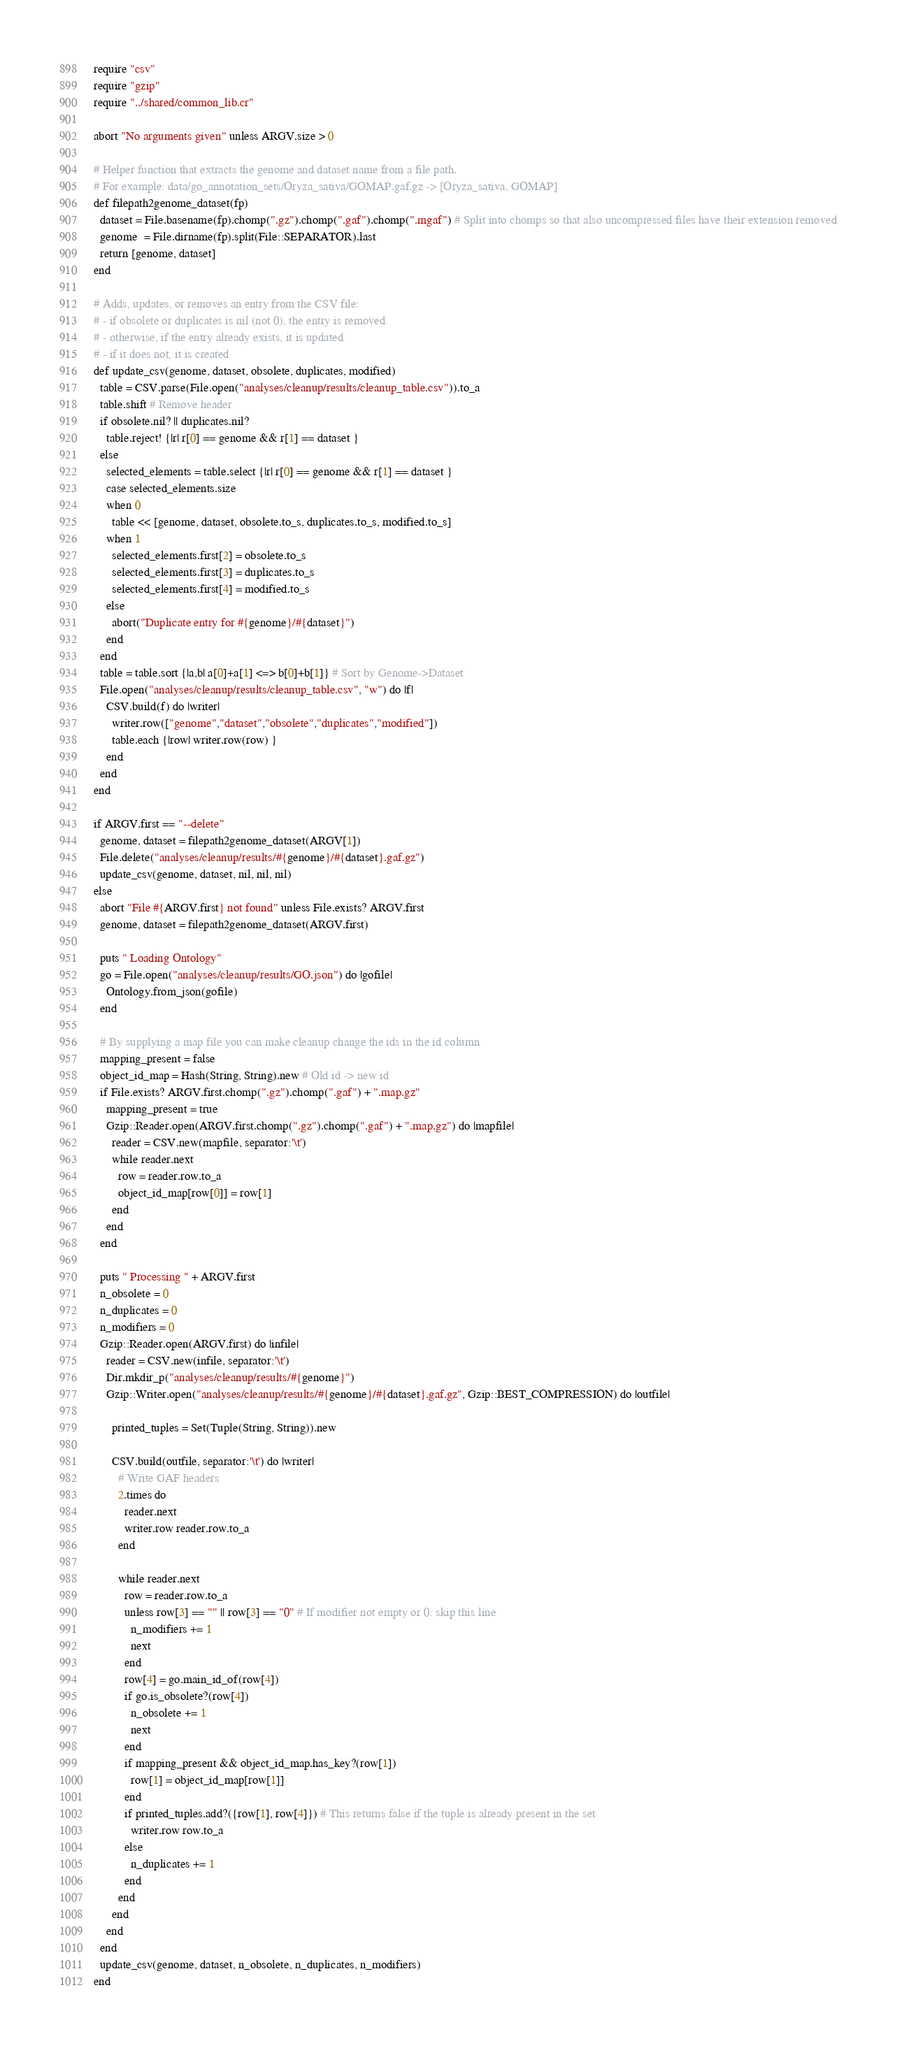Convert code to text. <code><loc_0><loc_0><loc_500><loc_500><_Crystal_>require "csv"
require "gzip"
require "../shared/common_lib.cr"

abort "No arguments given" unless ARGV.size > 0

# Helper function that extracts the genome and dataset name from a file path.
# For example: data/go_annotation_sets/Oryza_sativa/GOMAP.gaf.gz -> [Oryza_sativa, GOMAP]
def filepath2genome_dataset(fp)
  dataset = File.basename(fp).chomp(".gz").chomp(".gaf").chomp(".mgaf") # Split into chomps so that also uncompressed files have their extension removed
  genome  = File.dirname(fp).split(File::SEPARATOR).last
  return [genome, dataset]
end

# Adds, updates, or removes an entry from the CSV file:
# - if obsolete or duplicates is nil (not 0), the entry is removed
# - otherwise, if the entry already exists, it is updated
# - if it does not, it is created
def update_csv(genome, dataset, obsolete, duplicates, modified)
  table = CSV.parse(File.open("analyses/cleanup/results/cleanup_table.csv")).to_a
  table.shift # Remove header
  if obsolete.nil? || duplicates.nil?
    table.reject! {|r| r[0] == genome && r[1] == dataset }
  else
    selected_elements = table.select {|r| r[0] == genome && r[1] == dataset }
    case selected_elements.size
    when 0
      table << [genome, dataset, obsolete.to_s, duplicates.to_s, modified.to_s]
    when 1
      selected_elements.first[2] = obsolete.to_s
      selected_elements.first[3] = duplicates.to_s
      selected_elements.first[4] = modified.to_s
    else
      abort("Duplicate entry for #{genome}/#{dataset}")
    end
  end
  table = table.sort {|a,b| a[0]+a[1] <=> b[0]+b[1]} # Sort by Genome->Dataset
  File.open("analyses/cleanup/results/cleanup_table.csv", "w") do |f|
    CSV.build(f) do |writer|
      writer.row(["genome","dataset","obsolete","duplicates","modified"])
      table.each {|row| writer.row(row) }
    end
  end
end

if ARGV.first == "--delete"
  genome, dataset = filepath2genome_dataset(ARGV[1])
  File.delete("analyses/cleanup/results/#{genome}/#{dataset}.gaf.gz")
  update_csv(genome, dataset, nil, nil, nil)
else
  abort "File #{ARGV.first} not found" unless File.exists? ARGV.first
  genome, dataset = filepath2genome_dataset(ARGV.first)

  puts " Loading Ontology"
  go = File.open("analyses/cleanup/results/GO.json") do |gofile|
    Ontology.from_json(gofile)
  end

  # By supplying a map file you can make cleanup change the ids in the id column
  mapping_present = false
  object_id_map = Hash(String, String).new # Old id -> new id
  if File.exists? ARGV.first.chomp(".gz").chomp(".gaf") + ".map.gz"
    mapping_present = true
    Gzip::Reader.open(ARGV.first.chomp(".gz").chomp(".gaf") + ".map.gz") do |mapfile|
      reader = CSV.new(mapfile, separator:'\t')
      while reader.next
        row = reader.row.to_a
        object_id_map[row[0]] = row[1]
      end
    end
  end

  puts " Processing " + ARGV.first
  n_obsolete = 0
  n_duplicates = 0
  n_modifiers = 0
  Gzip::Reader.open(ARGV.first) do |infile|
    reader = CSV.new(infile, separator:'\t')
    Dir.mkdir_p("analyses/cleanup/results/#{genome}")
    Gzip::Writer.open("analyses/cleanup/results/#{genome}/#{dataset}.gaf.gz", Gzip::BEST_COMPRESSION) do |outfile|

      printed_tuples = Set(Tuple(String, String)).new

      CSV.build(outfile, separator:'\t') do |writer|
        # Write GAF headers
        2.times do
          reader.next
          writer.row reader.row.to_a
        end

        while reader.next
          row = reader.row.to_a
          unless row[3] == "" || row[3] == "0" # If modifier not empty or 0: skip this line
            n_modifiers += 1
            next
          end
          row[4] = go.main_id_of(row[4])
          if go.is_obsolete?(row[4])
            n_obsolete += 1
            next
          end
          if mapping_present && object_id_map.has_key?(row[1])
            row[1] = object_id_map[row[1]]
          end
          if printed_tuples.add?({row[1], row[4]}) # This returns false if the tuple is already present in the set
            writer.row row.to_a
          else
            n_duplicates += 1
          end
        end
      end
    end
  end
  update_csv(genome, dataset, n_obsolete, n_duplicates, n_modifiers)
end
</code> 